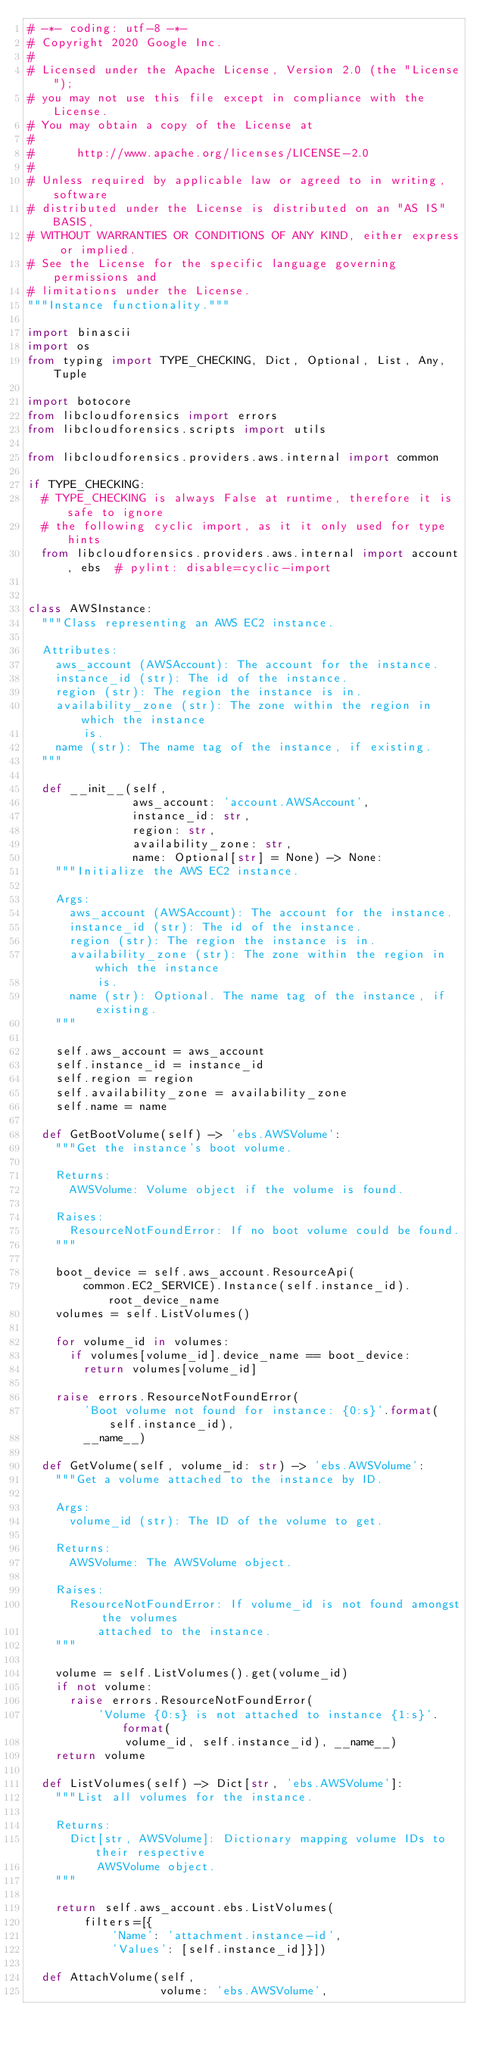<code> <loc_0><loc_0><loc_500><loc_500><_Python_># -*- coding: utf-8 -*-
# Copyright 2020 Google Inc.
#
# Licensed under the Apache License, Version 2.0 (the "License");
# you may not use this file except in compliance with the License.
# You may obtain a copy of the License at
#
#      http://www.apache.org/licenses/LICENSE-2.0
#
# Unless required by applicable law or agreed to in writing, software
# distributed under the License is distributed on an "AS IS" BASIS,
# WITHOUT WARRANTIES OR CONDITIONS OF ANY KIND, either express or implied.
# See the License for the specific language governing permissions and
# limitations under the License.
"""Instance functionality."""

import binascii
import os
from typing import TYPE_CHECKING, Dict, Optional, List, Any, Tuple

import botocore
from libcloudforensics import errors
from libcloudforensics.scripts import utils

from libcloudforensics.providers.aws.internal import common

if TYPE_CHECKING:
  # TYPE_CHECKING is always False at runtime, therefore it is safe to ignore
  # the following cyclic import, as it it only used for type hints
  from libcloudforensics.providers.aws.internal import account, ebs  # pylint: disable=cyclic-import


class AWSInstance:
  """Class representing an AWS EC2 instance.

  Attributes:
    aws_account (AWSAccount): The account for the instance.
    instance_id (str): The id of the instance.
    region (str): The region the instance is in.
    availability_zone (str): The zone within the region in which the instance
        is.
    name (str): The name tag of the instance, if existing.
  """

  def __init__(self,
               aws_account: 'account.AWSAccount',
               instance_id: str,
               region: str,
               availability_zone: str,
               name: Optional[str] = None) -> None:
    """Initialize the AWS EC2 instance.

    Args:
      aws_account (AWSAccount): The account for the instance.
      instance_id (str): The id of the instance.
      region (str): The region the instance is in.
      availability_zone (str): The zone within the region in which the instance
          is.
      name (str): Optional. The name tag of the instance, if existing.
    """

    self.aws_account = aws_account
    self.instance_id = instance_id
    self.region = region
    self.availability_zone = availability_zone
    self.name = name

  def GetBootVolume(self) -> 'ebs.AWSVolume':
    """Get the instance's boot volume.

    Returns:
      AWSVolume: Volume object if the volume is found.

    Raises:
      ResourceNotFoundError: If no boot volume could be found.
    """

    boot_device = self.aws_account.ResourceApi(
        common.EC2_SERVICE).Instance(self.instance_id).root_device_name
    volumes = self.ListVolumes()

    for volume_id in volumes:
      if volumes[volume_id].device_name == boot_device:
        return volumes[volume_id]

    raise errors.ResourceNotFoundError(
        'Boot volume not found for instance: {0:s}'.format(self.instance_id),
        __name__)

  def GetVolume(self, volume_id: str) -> 'ebs.AWSVolume':
    """Get a volume attached to the instance by ID.

    Args:
      volume_id (str): The ID of the volume to get.

    Returns:
      AWSVolume: The AWSVolume object.

    Raises:
      ResourceNotFoundError: If volume_id is not found amongst the volumes
          attached to the instance.
    """

    volume = self.ListVolumes().get(volume_id)
    if not volume:
      raise errors.ResourceNotFoundError(
          'Volume {0:s} is not attached to instance {1:s}'.format(
              volume_id, self.instance_id), __name__)
    return volume

  def ListVolumes(self) -> Dict[str, 'ebs.AWSVolume']:
    """List all volumes for the instance.

    Returns:
      Dict[str, AWSVolume]: Dictionary mapping volume IDs to their respective
          AWSVolume object.
    """

    return self.aws_account.ebs.ListVolumes(
        filters=[{
            'Name': 'attachment.instance-id',
            'Values': [self.instance_id]}])

  def AttachVolume(self,
                   volume: 'ebs.AWSVolume',</code> 